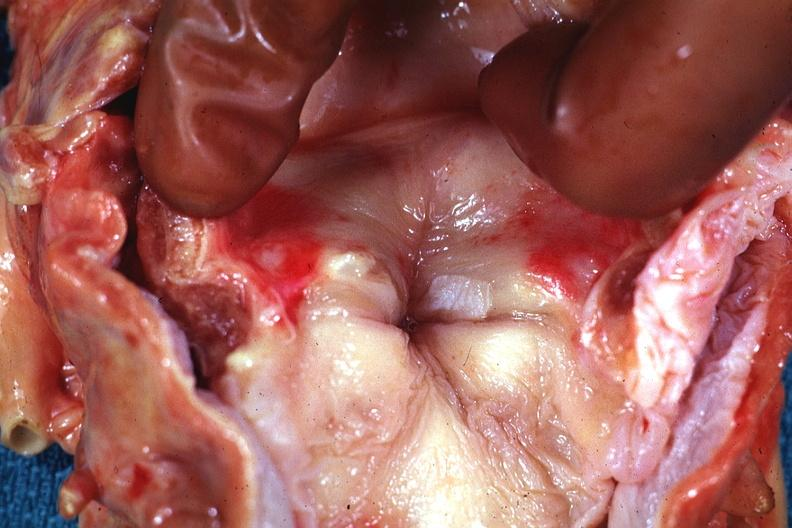where is this?
Answer the question using a single word or phrase. Oral 